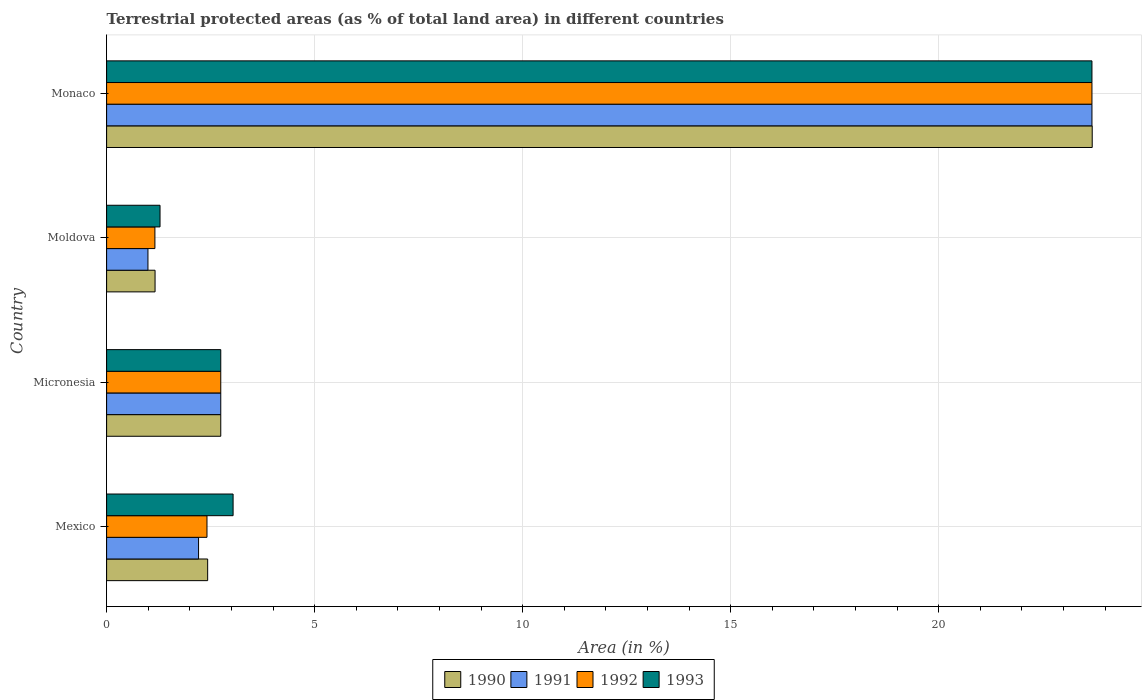How many different coloured bars are there?
Your answer should be very brief. 4. Are the number of bars on each tick of the Y-axis equal?
Ensure brevity in your answer.  Yes. What is the label of the 4th group of bars from the top?
Provide a short and direct response. Mexico. In how many cases, is the number of bars for a given country not equal to the number of legend labels?
Provide a short and direct response. 0. What is the percentage of terrestrial protected land in 1991 in Mexico?
Your answer should be compact. 2.21. Across all countries, what is the maximum percentage of terrestrial protected land in 1990?
Provide a short and direct response. 23.69. Across all countries, what is the minimum percentage of terrestrial protected land in 1993?
Offer a terse response. 1.28. In which country was the percentage of terrestrial protected land in 1991 maximum?
Provide a short and direct response. Monaco. In which country was the percentage of terrestrial protected land in 1991 minimum?
Provide a succinct answer. Moldova. What is the total percentage of terrestrial protected land in 1993 in the graph?
Offer a terse response. 30.75. What is the difference between the percentage of terrestrial protected land in 1993 in Micronesia and that in Moldova?
Offer a terse response. 1.46. What is the difference between the percentage of terrestrial protected land in 1992 in Mexico and the percentage of terrestrial protected land in 1993 in Micronesia?
Give a very brief answer. -0.33. What is the average percentage of terrestrial protected land in 1993 per country?
Make the answer very short. 7.69. What is the difference between the percentage of terrestrial protected land in 1991 and percentage of terrestrial protected land in 1992 in Moldova?
Your answer should be compact. -0.17. What is the ratio of the percentage of terrestrial protected land in 1993 in Moldova to that in Monaco?
Provide a succinct answer. 0.05. Is the percentage of terrestrial protected land in 1993 in Micronesia less than that in Moldova?
Make the answer very short. No. What is the difference between the highest and the second highest percentage of terrestrial protected land in 1992?
Give a very brief answer. 20.94. What is the difference between the highest and the lowest percentage of terrestrial protected land in 1993?
Ensure brevity in your answer.  22.4. Is the sum of the percentage of terrestrial protected land in 1990 in Moldova and Monaco greater than the maximum percentage of terrestrial protected land in 1991 across all countries?
Offer a very short reply. Yes. Is it the case that in every country, the sum of the percentage of terrestrial protected land in 1991 and percentage of terrestrial protected land in 1990 is greater than the percentage of terrestrial protected land in 1992?
Your answer should be compact. Yes. How many countries are there in the graph?
Give a very brief answer. 4. Does the graph contain grids?
Provide a short and direct response. Yes. How are the legend labels stacked?
Your answer should be very brief. Horizontal. What is the title of the graph?
Provide a succinct answer. Terrestrial protected areas (as % of total land area) in different countries. What is the label or title of the X-axis?
Keep it short and to the point. Area (in %). What is the Area (in %) in 1990 in Mexico?
Keep it short and to the point. 2.43. What is the Area (in %) in 1991 in Mexico?
Provide a short and direct response. 2.21. What is the Area (in %) in 1992 in Mexico?
Ensure brevity in your answer.  2.41. What is the Area (in %) of 1993 in Mexico?
Provide a succinct answer. 3.04. What is the Area (in %) of 1990 in Micronesia?
Your answer should be compact. 2.74. What is the Area (in %) in 1991 in Micronesia?
Ensure brevity in your answer.  2.74. What is the Area (in %) in 1992 in Micronesia?
Make the answer very short. 2.74. What is the Area (in %) in 1993 in Micronesia?
Offer a very short reply. 2.74. What is the Area (in %) in 1990 in Moldova?
Your response must be concise. 1.16. What is the Area (in %) in 1991 in Moldova?
Make the answer very short. 0.99. What is the Area (in %) in 1992 in Moldova?
Keep it short and to the point. 1.16. What is the Area (in %) of 1993 in Moldova?
Keep it short and to the point. 1.28. What is the Area (in %) of 1990 in Monaco?
Offer a terse response. 23.69. What is the Area (in %) in 1991 in Monaco?
Your response must be concise. 23.68. What is the Area (in %) of 1992 in Monaco?
Give a very brief answer. 23.68. What is the Area (in %) in 1993 in Monaco?
Make the answer very short. 23.68. Across all countries, what is the maximum Area (in %) in 1990?
Provide a succinct answer. 23.69. Across all countries, what is the maximum Area (in %) in 1991?
Keep it short and to the point. 23.68. Across all countries, what is the maximum Area (in %) in 1992?
Provide a succinct answer. 23.68. Across all countries, what is the maximum Area (in %) of 1993?
Give a very brief answer. 23.68. Across all countries, what is the minimum Area (in %) in 1990?
Provide a succinct answer. 1.16. Across all countries, what is the minimum Area (in %) of 1991?
Provide a short and direct response. 0.99. Across all countries, what is the minimum Area (in %) in 1992?
Provide a short and direct response. 1.16. Across all countries, what is the minimum Area (in %) in 1993?
Provide a short and direct response. 1.28. What is the total Area (in %) in 1990 in the graph?
Your response must be concise. 30.03. What is the total Area (in %) in 1991 in the graph?
Offer a terse response. 29.63. What is the total Area (in %) in 1992 in the graph?
Keep it short and to the point. 30. What is the total Area (in %) of 1993 in the graph?
Make the answer very short. 30.75. What is the difference between the Area (in %) of 1990 in Mexico and that in Micronesia?
Offer a terse response. -0.32. What is the difference between the Area (in %) in 1991 in Mexico and that in Micronesia?
Ensure brevity in your answer.  -0.53. What is the difference between the Area (in %) in 1992 in Mexico and that in Micronesia?
Make the answer very short. -0.33. What is the difference between the Area (in %) in 1993 in Mexico and that in Micronesia?
Your response must be concise. 0.3. What is the difference between the Area (in %) in 1990 in Mexico and that in Moldova?
Offer a terse response. 1.26. What is the difference between the Area (in %) of 1991 in Mexico and that in Moldova?
Offer a very short reply. 1.22. What is the difference between the Area (in %) in 1992 in Mexico and that in Moldova?
Keep it short and to the point. 1.25. What is the difference between the Area (in %) of 1993 in Mexico and that in Moldova?
Make the answer very short. 1.76. What is the difference between the Area (in %) of 1990 in Mexico and that in Monaco?
Make the answer very short. -21.26. What is the difference between the Area (in %) in 1991 in Mexico and that in Monaco?
Ensure brevity in your answer.  -21.47. What is the difference between the Area (in %) in 1992 in Mexico and that in Monaco?
Keep it short and to the point. -21.27. What is the difference between the Area (in %) in 1993 in Mexico and that in Monaco?
Provide a succinct answer. -20.64. What is the difference between the Area (in %) of 1990 in Micronesia and that in Moldova?
Offer a terse response. 1.58. What is the difference between the Area (in %) in 1991 in Micronesia and that in Moldova?
Keep it short and to the point. 1.75. What is the difference between the Area (in %) of 1992 in Micronesia and that in Moldova?
Provide a short and direct response. 1.58. What is the difference between the Area (in %) of 1993 in Micronesia and that in Moldova?
Ensure brevity in your answer.  1.46. What is the difference between the Area (in %) in 1990 in Micronesia and that in Monaco?
Make the answer very short. -20.95. What is the difference between the Area (in %) in 1991 in Micronesia and that in Monaco?
Provide a succinct answer. -20.94. What is the difference between the Area (in %) in 1992 in Micronesia and that in Monaco?
Offer a very short reply. -20.94. What is the difference between the Area (in %) of 1993 in Micronesia and that in Monaco?
Provide a succinct answer. -20.94. What is the difference between the Area (in %) in 1990 in Moldova and that in Monaco?
Offer a terse response. -22.53. What is the difference between the Area (in %) of 1991 in Moldova and that in Monaco?
Give a very brief answer. -22.69. What is the difference between the Area (in %) in 1992 in Moldova and that in Monaco?
Keep it short and to the point. -22.52. What is the difference between the Area (in %) in 1993 in Moldova and that in Monaco?
Keep it short and to the point. -22.4. What is the difference between the Area (in %) of 1990 in Mexico and the Area (in %) of 1991 in Micronesia?
Your answer should be compact. -0.32. What is the difference between the Area (in %) in 1990 in Mexico and the Area (in %) in 1992 in Micronesia?
Ensure brevity in your answer.  -0.32. What is the difference between the Area (in %) of 1990 in Mexico and the Area (in %) of 1993 in Micronesia?
Your answer should be very brief. -0.32. What is the difference between the Area (in %) of 1991 in Mexico and the Area (in %) of 1992 in Micronesia?
Your answer should be very brief. -0.53. What is the difference between the Area (in %) in 1991 in Mexico and the Area (in %) in 1993 in Micronesia?
Offer a terse response. -0.53. What is the difference between the Area (in %) in 1992 in Mexico and the Area (in %) in 1993 in Micronesia?
Make the answer very short. -0.33. What is the difference between the Area (in %) in 1990 in Mexico and the Area (in %) in 1991 in Moldova?
Give a very brief answer. 1.44. What is the difference between the Area (in %) in 1990 in Mexico and the Area (in %) in 1992 in Moldova?
Provide a short and direct response. 1.27. What is the difference between the Area (in %) of 1990 in Mexico and the Area (in %) of 1993 in Moldova?
Keep it short and to the point. 1.14. What is the difference between the Area (in %) of 1991 in Mexico and the Area (in %) of 1992 in Moldova?
Your answer should be very brief. 1.05. What is the difference between the Area (in %) in 1991 in Mexico and the Area (in %) in 1993 in Moldova?
Give a very brief answer. 0.93. What is the difference between the Area (in %) in 1992 in Mexico and the Area (in %) in 1993 in Moldova?
Your answer should be very brief. 1.13. What is the difference between the Area (in %) in 1990 in Mexico and the Area (in %) in 1991 in Monaco?
Make the answer very short. -21.26. What is the difference between the Area (in %) in 1990 in Mexico and the Area (in %) in 1992 in Monaco?
Offer a very short reply. -21.26. What is the difference between the Area (in %) in 1990 in Mexico and the Area (in %) in 1993 in Monaco?
Your response must be concise. -21.26. What is the difference between the Area (in %) in 1991 in Mexico and the Area (in %) in 1992 in Monaco?
Offer a terse response. -21.47. What is the difference between the Area (in %) in 1991 in Mexico and the Area (in %) in 1993 in Monaco?
Make the answer very short. -21.47. What is the difference between the Area (in %) in 1992 in Mexico and the Area (in %) in 1993 in Monaco?
Provide a succinct answer. -21.27. What is the difference between the Area (in %) in 1990 in Micronesia and the Area (in %) in 1991 in Moldova?
Keep it short and to the point. 1.75. What is the difference between the Area (in %) of 1990 in Micronesia and the Area (in %) of 1992 in Moldova?
Give a very brief answer. 1.58. What is the difference between the Area (in %) in 1990 in Micronesia and the Area (in %) in 1993 in Moldova?
Your response must be concise. 1.46. What is the difference between the Area (in %) in 1991 in Micronesia and the Area (in %) in 1992 in Moldova?
Your answer should be compact. 1.58. What is the difference between the Area (in %) of 1991 in Micronesia and the Area (in %) of 1993 in Moldova?
Make the answer very short. 1.46. What is the difference between the Area (in %) in 1992 in Micronesia and the Area (in %) in 1993 in Moldova?
Keep it short and to the point. 1.46. What is the difference between the Area (in %) in 1990 in Micronesia and the Area (in %) in 1991 in Monaco?
Give a very brief answer. -20.94. What is the difference between the Area (in %) of 1990 in Micronesia and the Area (in %) of 1992 in Monaco?
Make the answer very short. -20.94. What is the difference between the Area (in %) of 1990 in Micronesia and the Area (in %) of 1993 in Monaco?
Your response must be concise. -20.94. What is the difference between the Area (in %) of 1991 in Micronesia and the Area (in %) of 1992 in Monaco?
Ensure brevity in your answer.  -20.94. What is the difference between the Area (in %) of 1991 in Micronesia and the Area (in %) of 1993 in Monaco?
Your answer should be very brief. -20.94. What is the difference between the Area (in %) of 1992 in Micronesia and the Area (in %) of 1993 in Monaco?
Provide a succinct answer. -20.94. What is the difference between the Area (in %) in 1990 in Moldova and the Area (in %) in 1991 in Monaco?
Your answer should be compact. -22.52. What is the difference between the Area (in %) in 1990 in Moldova and the Area (in %) in 1992 in Monaco?
Offer a terse response. -22.52. What is the difference between the Area (in %) in 1990 in Moldova and the Area (in %) in 1993 in Monaco?
Your answer should be very brief. -22.52. What is the difference between the Area (in %) of 1991 in Moldova and the Area (in %) of 1992 in Monaco?
Make the answer very short. -22.69. What is the difference between the Area (in %) of 1991 in Moldova and the Area (in %) of 1993 in Monaco?
Provide a short and direct response. -22.69. What is the difference between the Area (in %) in 1992 in Moldova and the Area (in %) in 1993 in Monaco?
Provide a succinct answer. -22.52. What is the average Area (in %) of 1990 per country?
Make the answer very short. 7.51. What is the average Area (in %) of 1991 per country?
Give a very brief answer. 7.41. What is the average Area (in %) in 1992 per country?
Give a very brief answer. 7.5. What is the average Area (in %) in 1993 per country?
Your answer should be compact. 7.69. What is the difference between the Area (in %) of 1990 and Area (in %) of 1991 in Mexico?
Provide a succinct answer. 0.22. What is the difference between the Area (in %) in 1990 and Area (in %) in 1992 in Mexico?
Provide a short and direct response. 0.02. What is the difference between the Area (in %) in 1990 and Area (in %) in 1993 in Mexico?
Offer a terse response. -0.61. What is the difference between the Area (in %) of 1991 and Area (in %) of 1992 in Mexico?
Make the answer very short. -0.2. What is the difference between the Area (in %) of 1991 and Area (in %) of 1993 in Mexico?
Your response must be concise. -0.83. What is the difference between the Area (in %) of 1992 and Area (in %) of 1993 in Mexico?
Give a very brief answer. -0.63. What is the difference between the Area (in %) of 1990 and Area (in %) of 1991 in Micronesia?
Offer a very short reply. -0. What is the difference between the Area (in %) in 1990 and Area (in %) in 1992 in Micronesia?
Ensure brevity in your answer.  -0. What is the difference between the Area (in %) in 1990 and Area (in %) in 1993 in Micronesia?
Your response must be concise. -0. What is the difference between the Area (in %) in 1991 and Area (in %) in 1992 in Micronesia?
Your response must be concise. 0. What is the difference between the Area (in %) of 1991 and Area (in %) of 1993 in Micronesia?
Provide a short and direct response. 0. What is the difference between the Area (in %) in 1992 and Area (in %) in 1993 in Micronesia?
Your answer should be compact. 0. What is the difference between the Area (in %) in 1990 and Area (in %) in 1991 in Moldova?
Your answer should be very brief. 0.17. What is the difference between the Area (in %) in 1990 and Area (in %) in 1992 in Moldova?
Your answer should be very brief. 0. What is the difference between the Area (in %) of 1990 and Area (in %) of 1993 in Moldova?
Your answer should be very brief. -0.12. What is the difference between the Area (in %) of 1991 and Area (in %) of 1992 in Moldova?
Your answer should be compact. -0.17. What is the difference between the Area (in %) in 1991 and Area (in %) in 1993 in Moldova?
Make the answer very short. -0.29. What is the difference between the Area (in %) of 1992 and Area (in %) of 1993 in Moldova?
Offer a terse response. -0.12. What is the difference between the Area (in %) of 1990 and Area (in %) of 1991 in Monaco?
Your answer should be very brief. 0.01. What is the difference between the Area (in %) of 1990 and Area (in %) of 1992 in Monaco?
Make the answer very short. 0.01. What is the difference between the Area (in %) of 1990 and Area (in %) of 1993 in Monaco?
Provide a succinct answer. 0.01. What is the difference between the Area (in %) in 1991 and Area (in %) in 1992 in Monaco?
Offer a very short reply. 0. What is the difference between the Area (in %) of 1992 and Area (in %) of 1993 in Monaco?
Give a very brief answer. 0. What is the ratio of the Area (in %) of 1990 in Mexico to that in Micronesia?
Give a very brief answer. 0.89. What is the ratio of the Area (in %) of 1991 in Mexico to that in Micronesia?
Offer a terse response. 0.81. What is the ratio of the Area (in %) in 1992 in Mexico to that in Micronesia?
Keep it short and to the point. 0.88. What is the ratio of the Area (in %) of 1993 in Mexico to that in Micronesia?
Give a very brief answer. 1.11. What is the ratio of the Area (in %) of 1990 in Mexico to that in Moldova?
Your answer should be very brief. 2.09. What is the ratio of the Area (in %) of 1991 in Mexico to that in Moldova?
Keep it short and to the point. 2.22. What is the ratio of the Area (in %) of 1992 in Mexico to that in Moldova?
Your answer should be compact. 2.08. What is the ratio of the Area (in %) of 1993 in Mexico to that in Moldova?
Provide a short and direct response. 2.37. What is the ratio of the Area (in %) in 1990 in Mexico to that in Monaco?
Your answer should be compact. 0.1. What is the ratio of the Area (in %) of 1991 in Mexico to that in Monaco?
Offer a very short reply. 0.09. What is the ratio of the Area (in %) of 1992 in Mexico to that in Monaco?
Your answer should be compact. 0.1. What is the ratio of the Area (in %) in 1993 in Mexico to that in Monaco?
Your response must be concise. 0.13. What is the ratio of the Area (in %) in 1990 in Micronesia to that in Moldova?
Provide a succinct answer. 2.36. What is the ratio of the Area (in %) in 1991 in Micronesia to that in Moldova?
Offer a terse response. 2.76. What is the ratio of the Area (in %) in 1992 in Micronesia to that in Moldova?
Your response must be concise. 2.36. What is the ratio of the Area (in %) of 1993 in Micronesia to that in Moldova?
Offer a very short reply. 2.14. What is the ratio of the Area (in %) of 1990 in Micronesia to that in Monaco?
Your response must be concise. 0.12. What is the ratio of the Area (in %) in 1991 in Micronesia to that in Monaco?
Keep it short and to the point. 0.12. What is the ratio of the Area (in %) in 1992 in Micronesia to that in Monaco?
Provide a short and direct response. 0.12. What is the ratio of the Area (in %) of 1993 in Micronesia to that in Monaco?
Offer a terse response. 0.12. What is the ratio of the Area (in %) in 1990 in Moldova to that in Monaco?
Your answer should be compact. 0.05. What is the ratio of the Area (in %) of 1991 in Moldova to that in Monaco?
Keep it short and to the point. 0.04. What is the ratio of the Area (in %) of 1992 in Moldova to that in Monaco?
Keep it short and to the point. 0.05. What is the ratio of the Area (in %) in 1993 in Moldova to that in Monaco?
Make the answer very short. 0.05. What is the difference between the highest and the second highest Area (in %) in 1990?
Ensure brevity in your answer.  20.95. What is the difference between the highest and the second highest Area (in %) of 1991?
Make the answer very short. 20.94. What is the difference between the highest and the second highest Area (in %) of 1992?
Ensure brevity in your answer.  20.94. What is the difference between the highest and the second highest Area (in %) in 1993?
Keep it short and to the point. 20.64. What is the difference between the highest and the lowest Area (in %) of 1990?
Make the answer very short. 22.53. What is the difference between the highest and the lowest Area (in %) in 1991?
Offer a terse response. 22.69. What is the difference between the highest and the lowest Area (in %) of 1992?
Keep it short and to the point. 22.52. What is the difference between the highest and the lowest Area (in %) in 1993?
Make the answer very short. 22.4. 